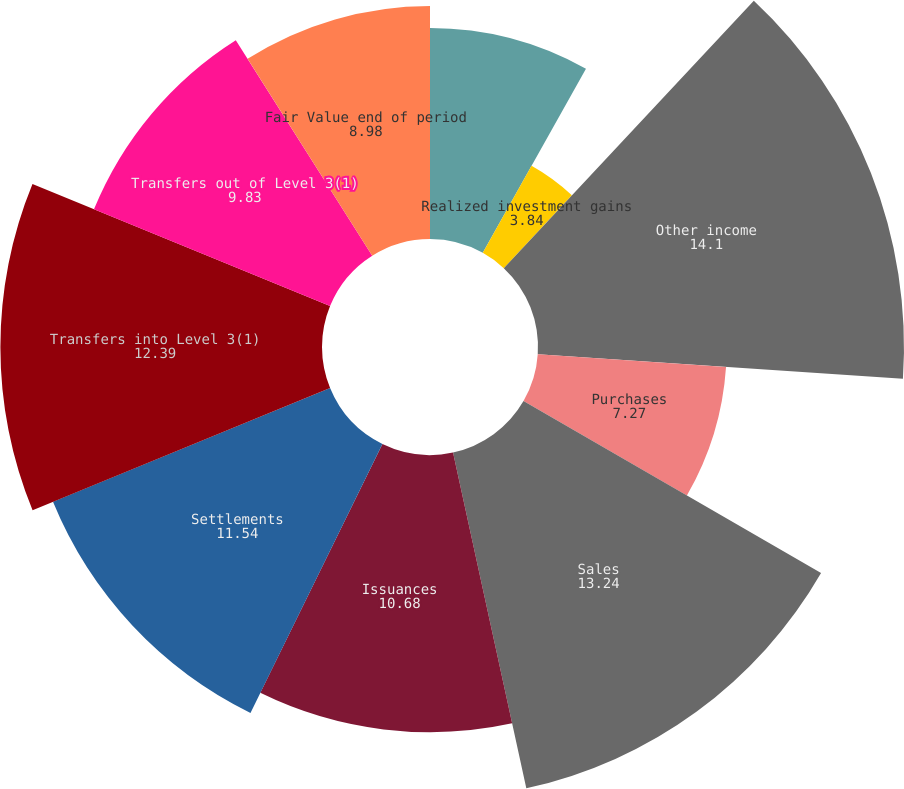Convert chart to OTSL. <chart><loc_0><loc_0><loc_500><loc_500><pie_chart><fcel>Fair Value beginning of period<fcel>Realized investment gains<fcel>Other income<fcel>Purchases<fcel>Sales<fcel>Issuances<fcel>Settlements<fcel>Transfers into Level 3(1)<fcel>Transfers out of Level 3(1)<fcel>Fair Value end of period<nl><fcel>8.13%<fcel>3.84%<fcel>14.1%<fcel>7.27%<fcel>13.24%<fcel>10.68%<fcel>11.54%<fcel>12.39%<fcel>9.83%<fcel>8.98%<nl></chart> 